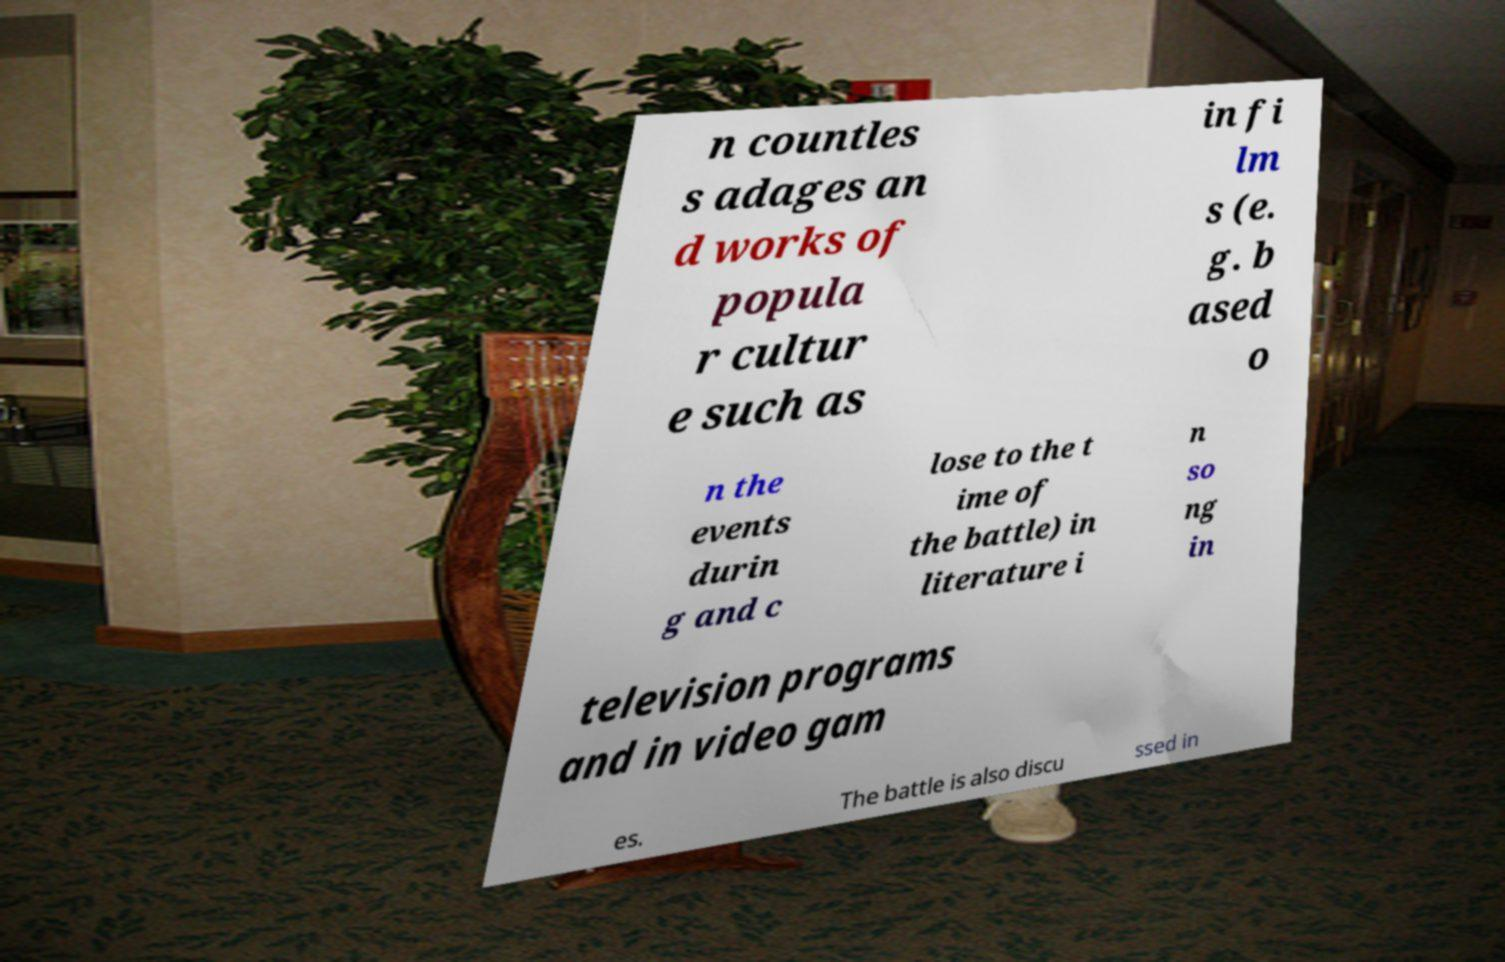There's text embedded in this image that I need extracted. Can you transcribe it verbatim? n countles s adages an d works of popula r cultur e such as in fi lm s (e. g. b ased o n the events durin g and c lose to the t ime of the battle) in literature i n so ng in television programs and in video gam es. The battle is also discu ssed in 